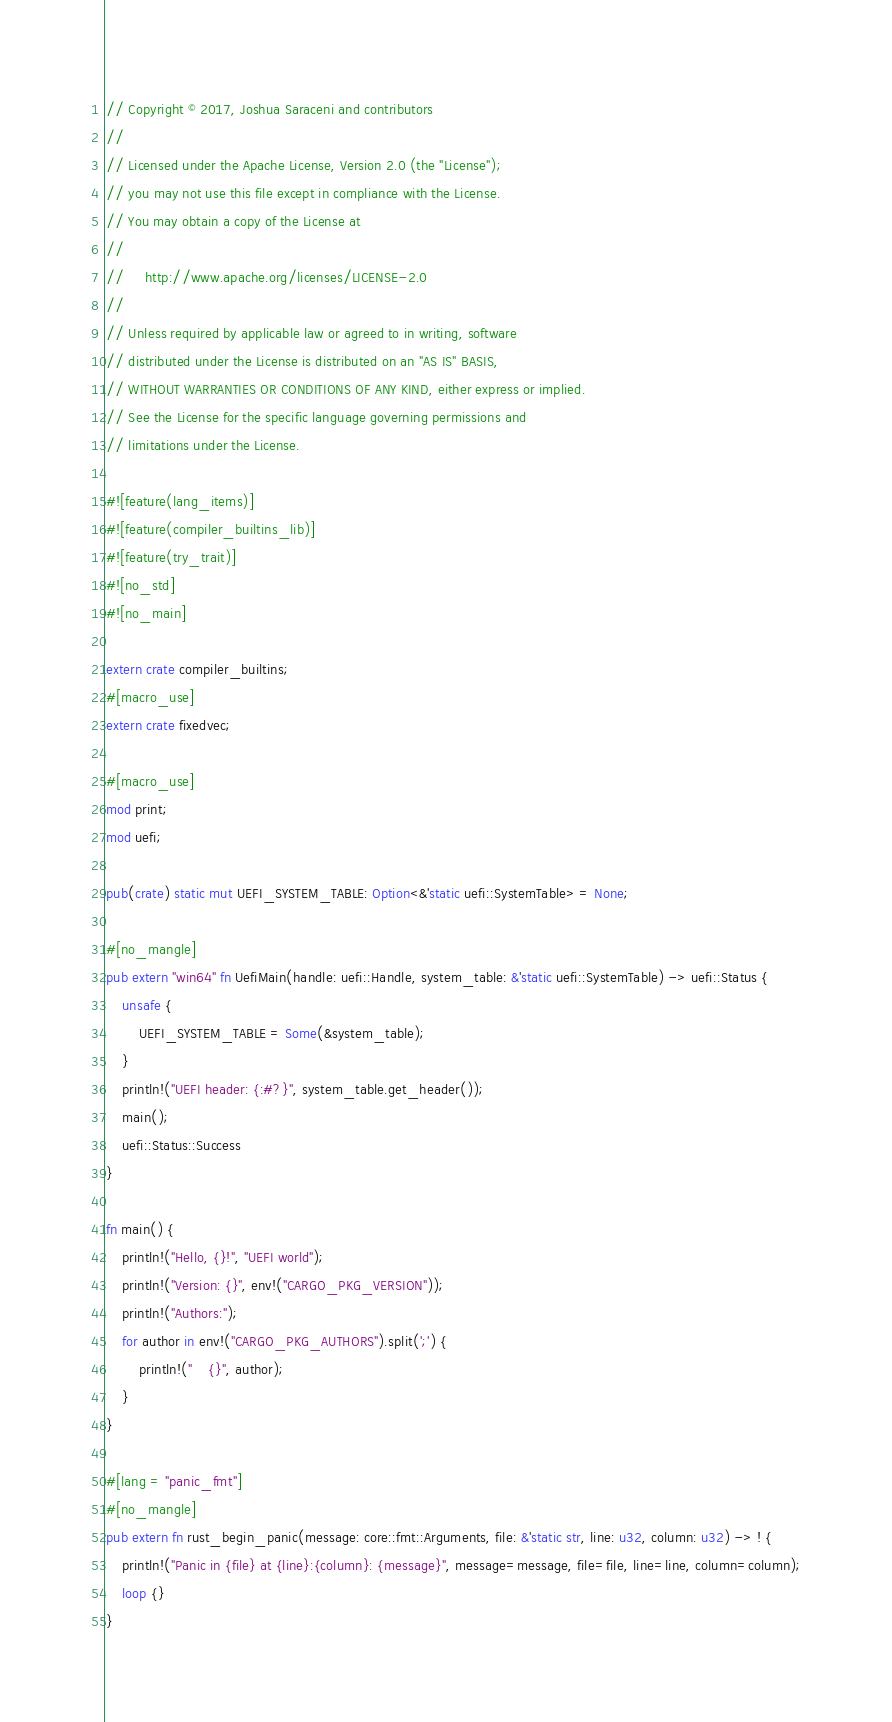<code> <loc_0><loc_0><loc_500><loc_500><_Rust_>// Copyright © 2017, Joshua Saraceni and contributors
// 
// Licensed under the Apache License, Version 2.0 (the "License");
// you may not use this file except in compliance with the License.
// You may obtain a copy of the License at
// 
//     http://www.apache.org/licenses/LICENSE-2.0
// 
// Unless required by applicable law or agreed to in writing, software
// distributed under the License is distributed on an "AS IS" BASIS,
// WITHOUT WARRANTIES OR CONDITIONS OF ANY KIND, either express or implied.
// See the License for the specific language governing permissions and
// limitations under the License.

#![feature(lang_items)]
#![feature(compiler_builtins_lib)]
#![feature(try_trait)]
#![no_std]
#![no_main]

extern crate compiler_builtins;
#[macro_use]
extern crate fixedvec;

#[macro_use]
mod print;
mod uefi;

pub(crate) static mut UEFI_SYSTEM_TABLE: Option<&'static uefi::SystemTable> = None;

#[no_mangle]
pub extern "win64" fn UefiMain(handle: uefi::Handle, system_table: &'static uefi::SystemTable) -> uefi::Status {
    unsafe {
        UEFI_SYSTEM_TABLE = Some(&system_table);
    }
    println!("UEFI header: {:#?}", system_table.get_header());
    main();
    uefi::Status::Success
}

fn main() {
    println!("Hello, {}!", "UEFI world");
    println!("Version: {}", env!("CARGO_PKG_VERSION"));
    println!("Authors:");
    for author in env!("CARGO_PKG_AUTHORS").split(';') {
        println!("    {}", author);
    }
}

#[lang = "panic_fmt"]
#[no_mangle]
pub extern fn rust_begin_panic(message: core::fmt::Arguments, file: &'static str, line: u32, column: u32) -> ! {
    println!("Panic in {file} at {line}:{column}: {message}", message=message, file=file, line=line, column=column);
    loop {}
}
</code> 